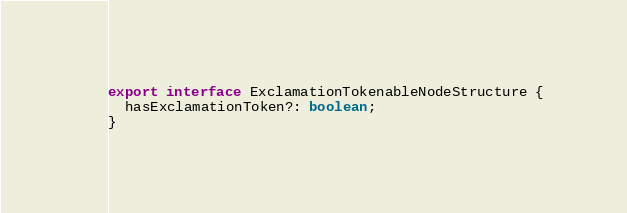<code> <loc_0><loc_0><loc_500><loc_500><_TypeScript_>export interface ExclamationTokenableNodeStructure {
  hasExclamationToken?: boolean;
}
</code> 